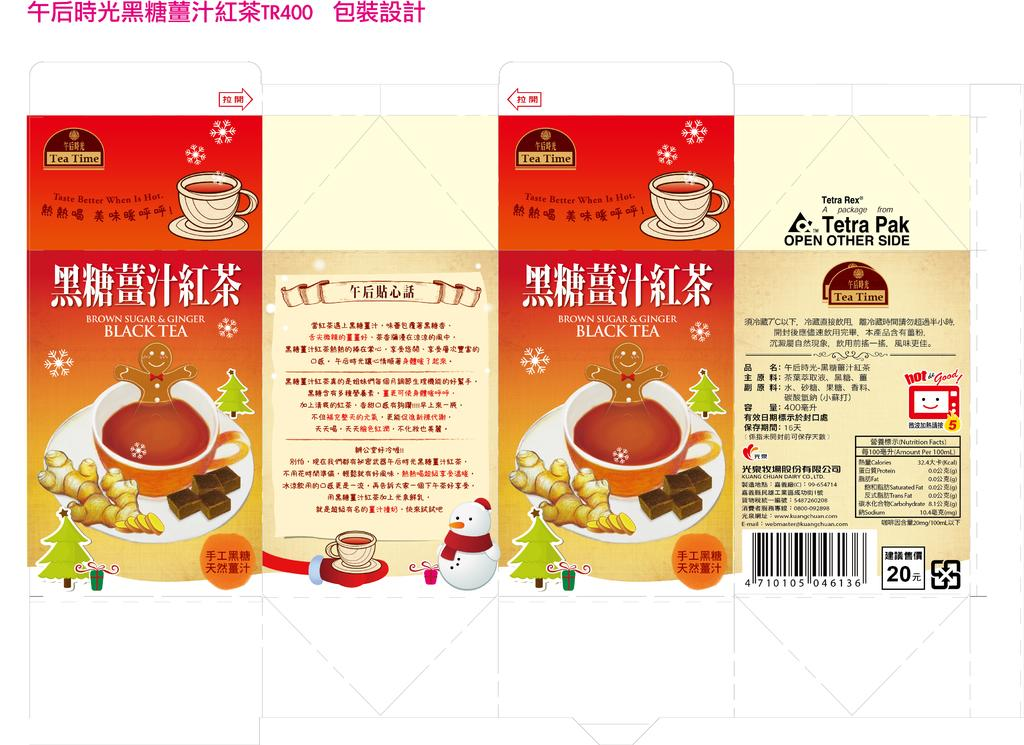What type of objects can be seen on the walls in the image? There are posters in the image. What is featured on the posters? There is writing on the posters. What type of containers are visible in the image? There are cups visible in the image. Can you describe any additional features of the image? There is a watermark at the top of the image. What type of pies are being produced in the image? There is no mention of pies or any production process in the image. The image features posters, writing on the posters, cups, and a watermark. 